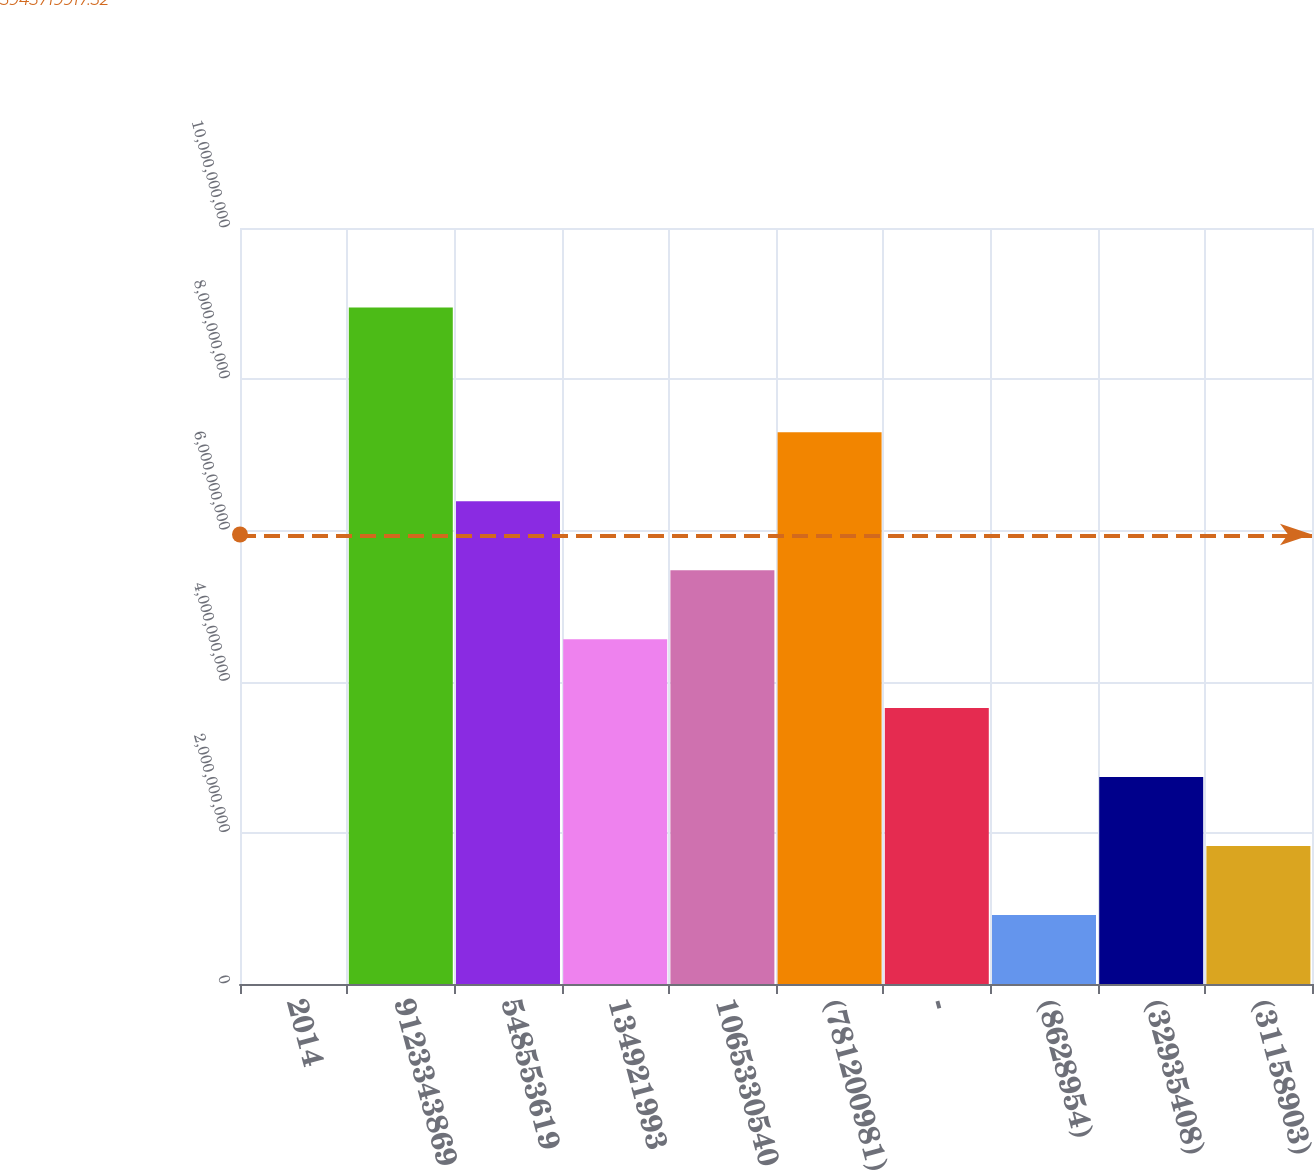Convert chart. <chart><loc_0><loc_0><loc_500><loc_500><bar_chart><fcel>2014<fcel>9123343869<fcel>548553619<fcel>134921993<fcel>1065330540<fcel>(781200981)<fcel>-<fcel>(8628954)<fcel>(32935408)<fcel>(31158903)<nl><fcel>2013<fcel>8.94729e+09<fcel>6.38634e+09<fcel>4.56167e+09<fcel>5.47401e+09<fcel>7.29868e+09<fcel>3.64934e+09<fcel>9.12336e+08<fcel>2.737e+09<fcel>1.82467e+09<nl></chart> 